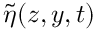<formula> <loc_0><loc_0><loc_500><loc_500>\tilde { \eta } ( z , y , t )</formula> 